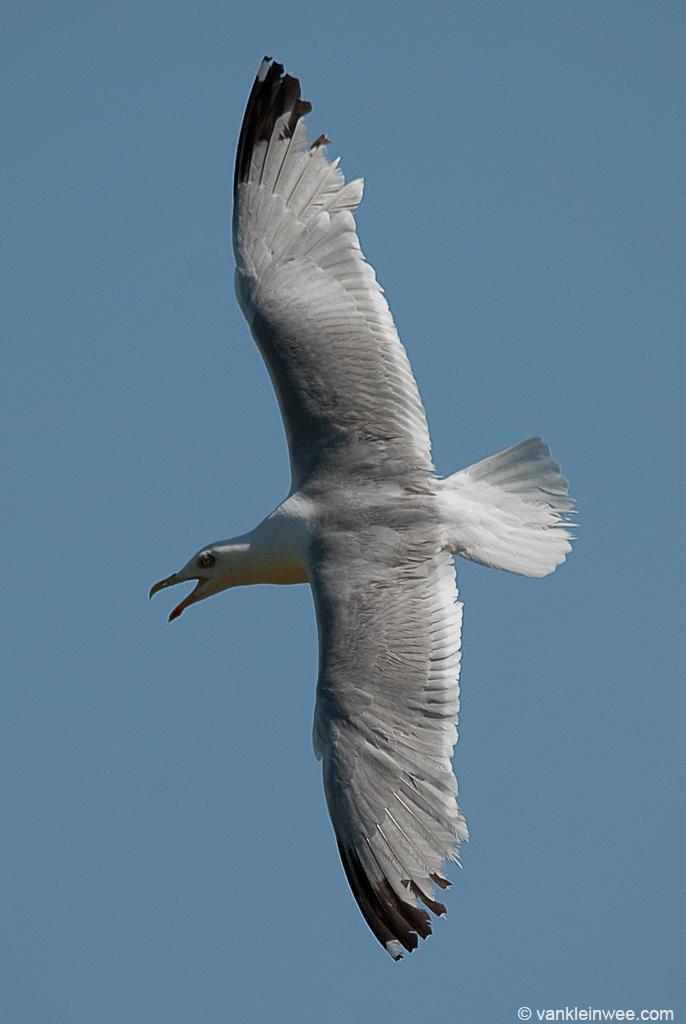Can you describe this image briefly? In this image there is a bird in the air. In the background of the image there is sky. There is some text at the bottom of the image. 